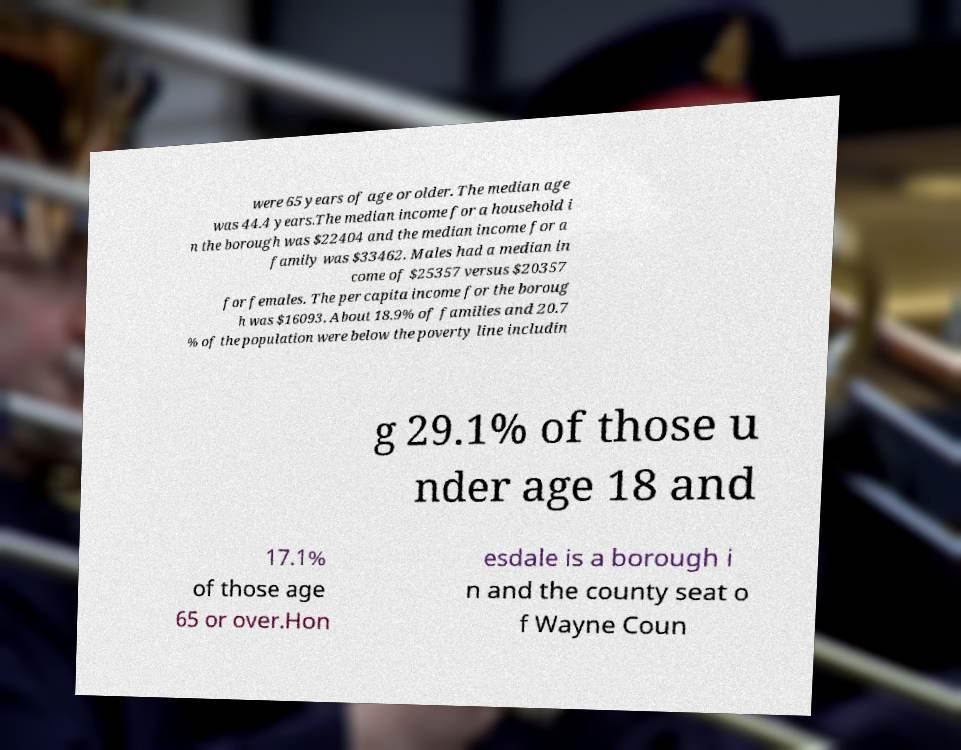Could you extract and type out the text from this image? were 65 years of age or older. The median age was 44.4 years.The median income for a household i n the borough was $22404 and the median income for a family was $33462. Males had a median in come of $25357 versus $20357 for females. The per capita income for the boroug h was $16093. About 18.9% of families and 20.7 % of the population were below the poverty line includin g 29.1% of those u nder age 18 and 17.1% of those age 65 or over.Hon esdale is a borough i n and the county seat o f Wayne Coun 